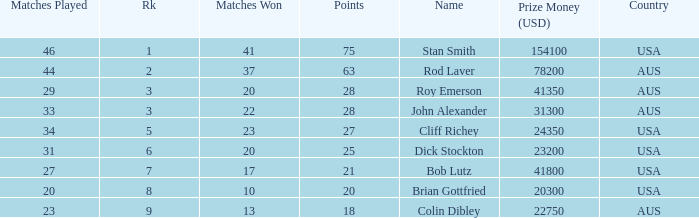How many matches did the player that played 23 matches win 13.0. 